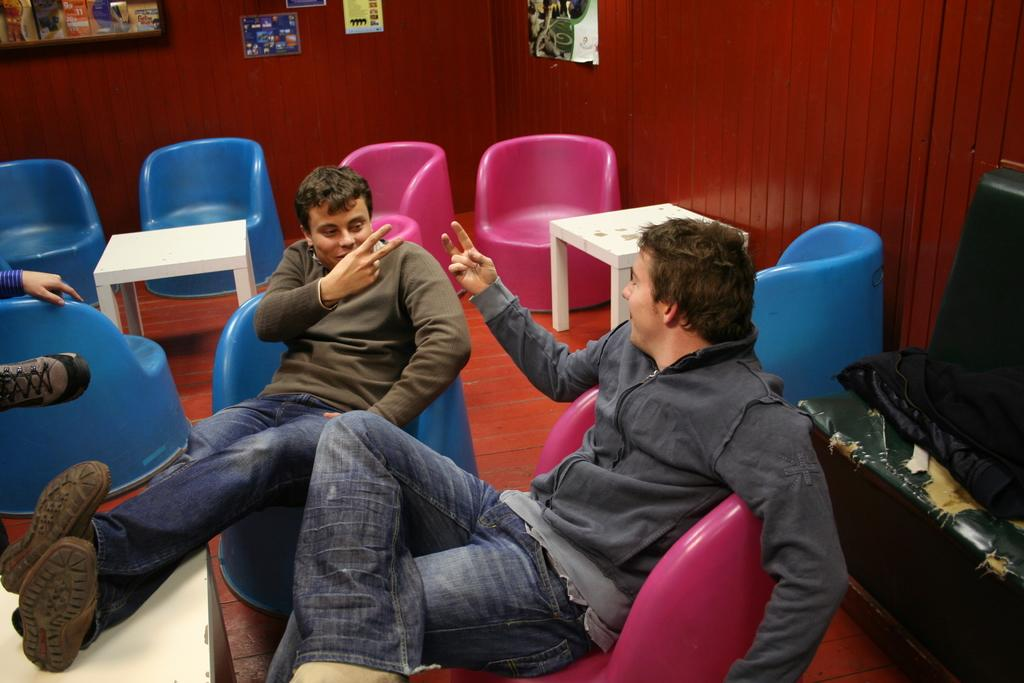How many people are sitting in the image? There are two persons sitting on chairs in the image. What is located on the right side of the image? There is a table on the right side of the image. What items can be seen on the table? There is a bag and a pillow on the table. What can be seen in the background of the image? There is a red color wall, a frame, and posters in the background. Is there a pen being used by one of the persons in the image? There is no pen visible in the image. Can you describe the rainstorm happening outside the window in the image? There is no window or rainstorm present in the image. 